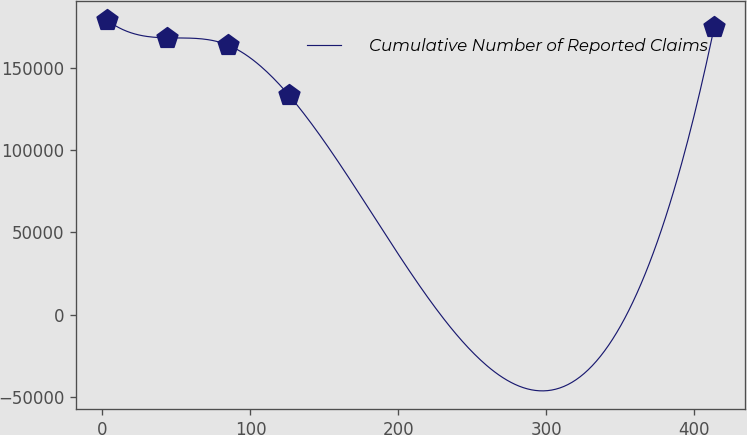Convert chart to OTSL. <chart><loc_0><loc_0><loc_500><loc_500><line_chart><ecel><fcel>Cumulative Number of Reported Claims<nl><fcel>2.71<fcel>179496<nl><fcel>43.79<fcel>168448<nl><fcel>84.87<fcel>164037<nl><fcel>125.95<fcel>133604<nl><fcel>413.46<fcel>175085<nl></chart> 